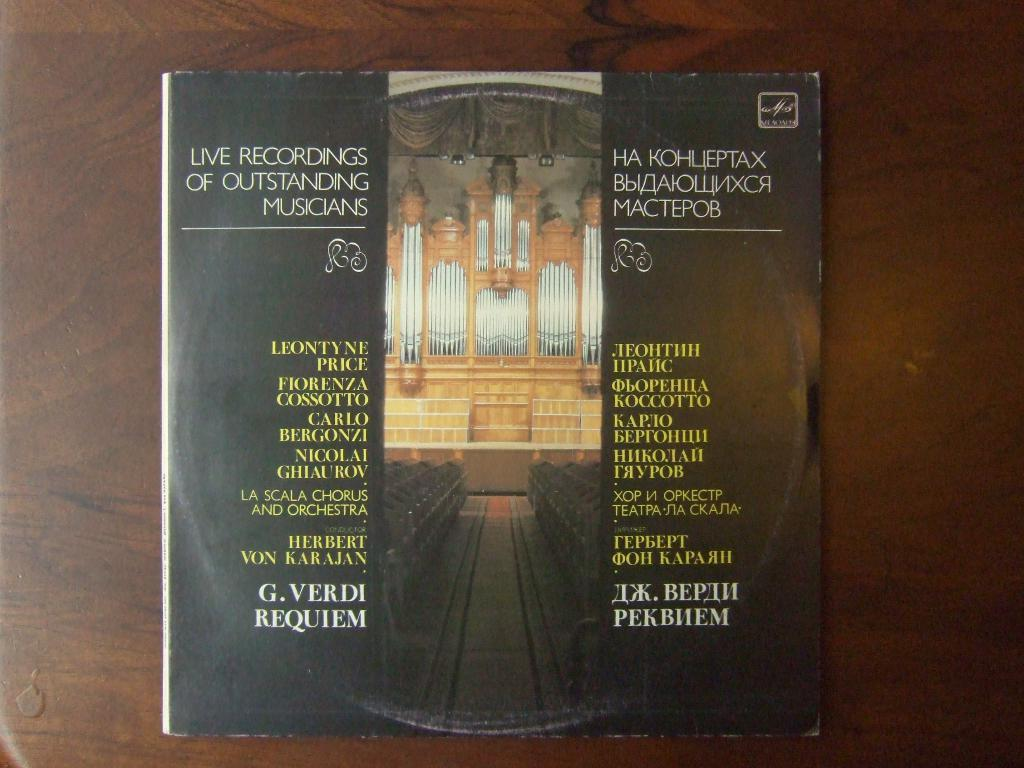<image>
Provide a brief description of the given image. A music CD with the backside reading Live Recordings. 